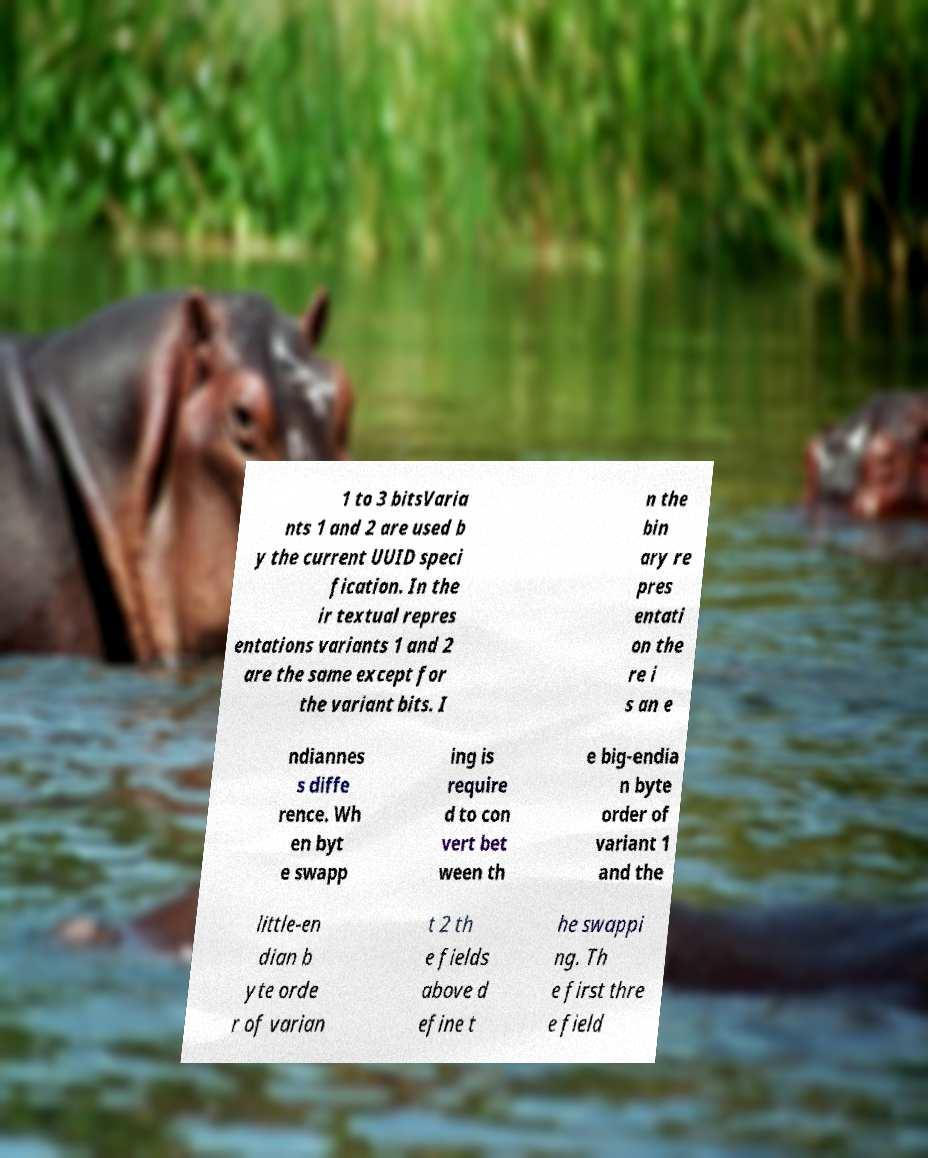For documentation purposes, I need the text within this image transcribed. Could you provide that? 1 to 3 bitsVaria nts 1 and 2 are used b y the current UUID speci fication. In the ir textual repres entations variants 1 and 2 are the same except for the variant bits. I n the bin ary re pres entati on the re i s an e ndiannes s diffe rence. Wh en byt e swapp ing is require d to con vert bet ween th e big-endia n byte order of variant 1 and the little-en dian b yte orde r of varian t 2 th e fields above d efine t he swappi ng. Th e first thre e field 